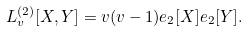Convert formula to latex. <formula><loc_0><loc_0><loc_500><loc_500>L _ { v } ^ { ( 2 ) } [ X , Y ] = v ( v - 1 ) e _ { 2 } [ X ] e _ { 2 } [ Y ] .</formula> 